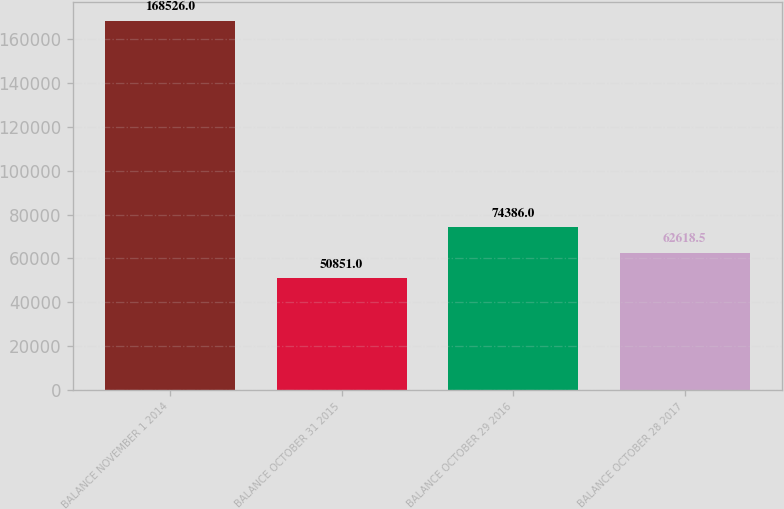<chart> <loc_0><loc_0><loc_500><loc_500><bar_chart><fcel>BALANCE NOVEMBER 1 2014<fcel>BALANCE OCTOBER 31 2015<fcel>BALANCE OCTOBER 29 2016<fcel>BALANCE OCTOBER 28 2017<nl><fcel>168526<fcel>50851<fcel>74386<fcel>62618.5<nl></chart> 